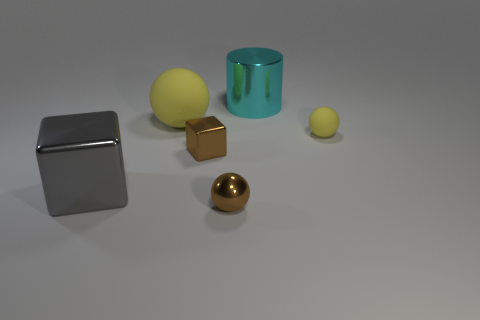Does the cyan cylinder have the same size as the brown metallic block?
Ensure brevity in your answer.  No. How many spheres are tiny matte things or rubber things?
Provide a short and direct response. 2. The large thing that is right of the rubber object on the left side of the big cyan shiny cylinder is what color?
Your response must be concise. Cyan. Is the number of cylinders that are in front of the cyan cylinder less than the number of metal cubes on the left side of the large gray thing?
Provide a succinct answer. No. There is a cyan metal object; is its size the same as the metal thing in front of the large gray object?
Give a very brief answer. No. There is a large object that is both in front of the cyan metal cylinder and on the right side of the big shiny cube; what shape is it?
Provide a succinct answer. Sphere. There is a cylinder that is the same material as the tiny brown block; what size is it?
Keep it short and to the point. Large. There is a tiny brown ball in front of the large cylinder; how many brown objects are behind it?
Your response must be concise. 1. Does the yellow ball left of the tiny rubber sphere have the same material as the tiny yellow sphere?
Provide a succinct answer. Yes. Is there any other thing that has the same material as the small yellow ball?
Your response must be concise. Yes. 